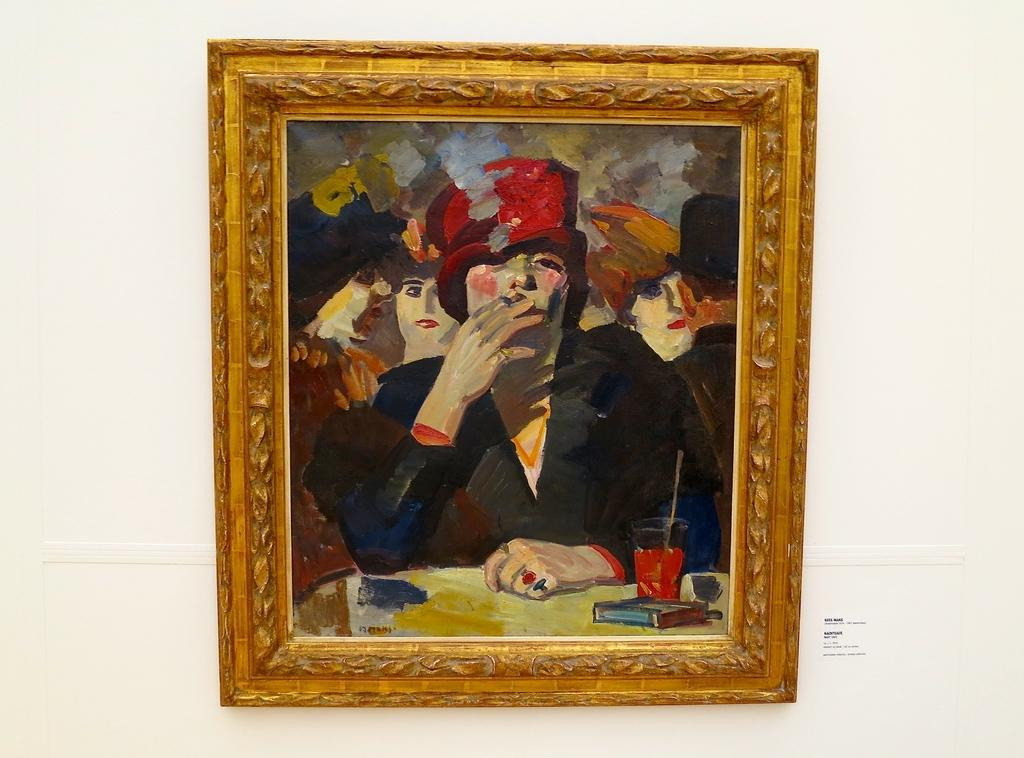What object can be seen in the image that is typically used for displaying photos? There is a photo frame in the image. Where is the photo frame located? The photo frame is on a wall. What type of food is being prepared in the photo frame? There is no food present in the image, as it features a photo frame on a wall. Can you see any crayons or fairies in the image? No, there are no crayons or fairies present in the image. 